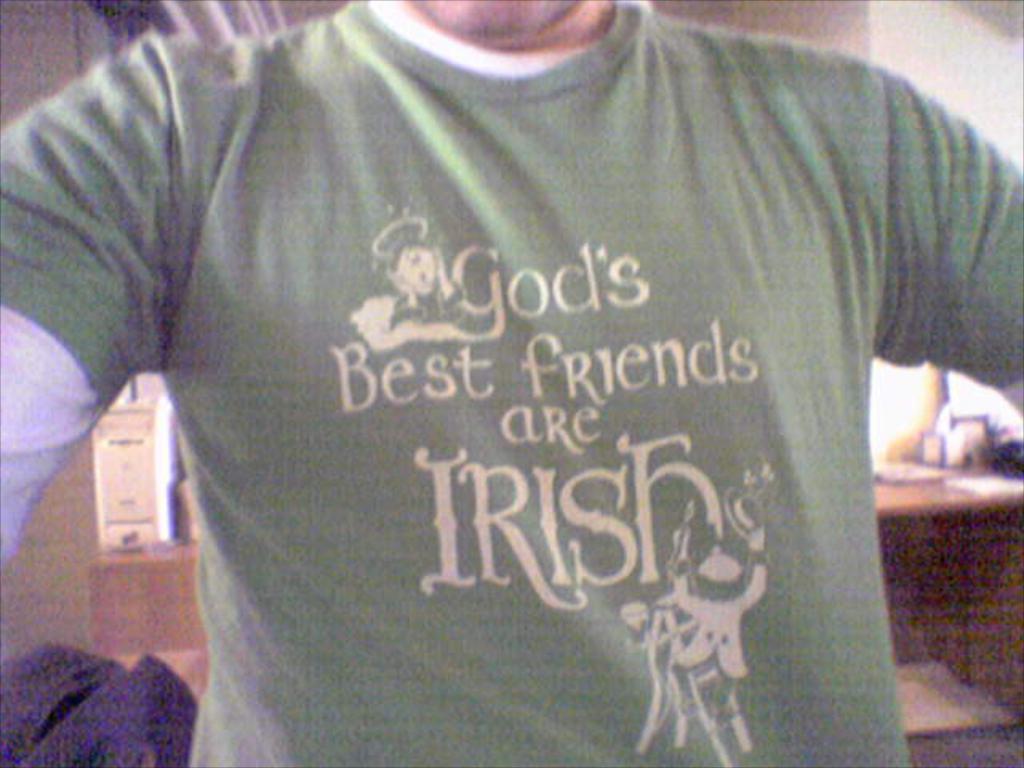Describe this image in one or two sentences. In this image there is a man he is wearing green a white color T-shirt. 